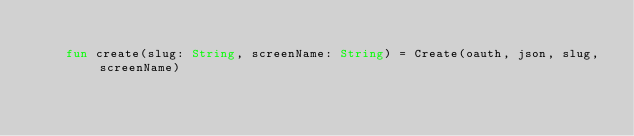<code> <loc_0><loc_0><loc_500><loc_500><_Kotlin_>
    fun create(slug: String, screenName: String) = Create(oauth, json, slug, screenName)
</code> 